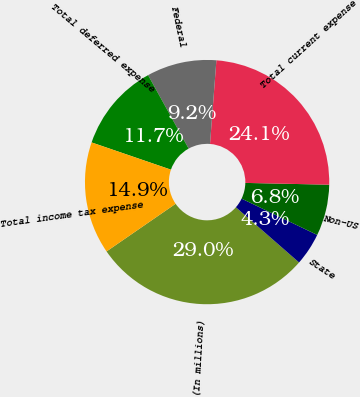Convert chart to OTSL. <chart><loc_0><loc_0><loc_500><loc_500><pie_chart><fcel>(In millions)<fcel>State<fcel>Non-US<fcel>Total current expense<fcel>Federal<fcel>Total deferred expense<fcel>Total income tax expense<nl><fcel>28.96%<fcel>4.31%<fcel>6.78%<fcel>24.13%<fcel>9.24%<fcel>11.71%<fcel>14.87%<nl></chart> 